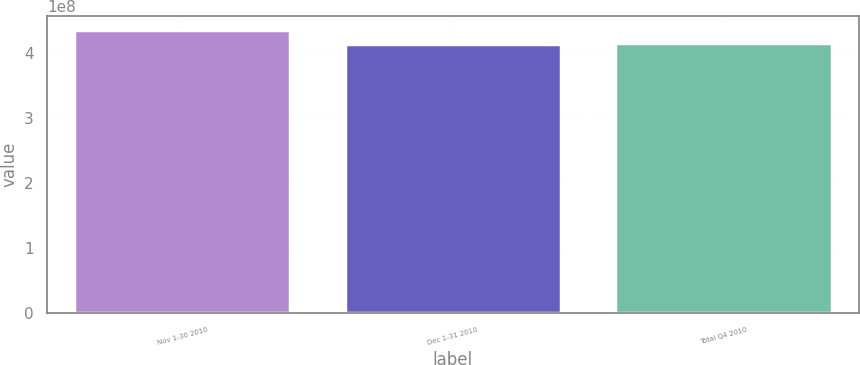Convert chart. <chart><loc_0><loc_0><loc_500><loc_500><bar_chart><fcel>Nov 1-30 2010<fcel>Dec 1-31 2010<fcel>Total Q4 2010<nl><fcel>4.36125e+08<fcel>4.14497e+08<fcel>4.1666e+08<nl></chart> 